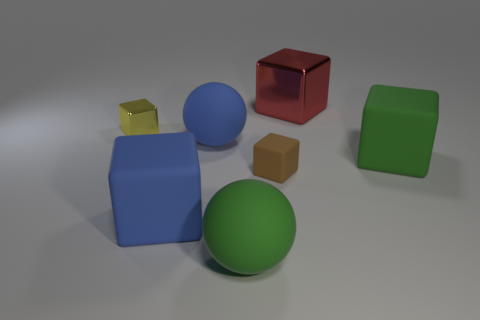Is the shape of the brown matte thing the same as the object that is on the left side of the big blue block?
Offer a very short reply. Yes. What material is the small cube in front of the shiny object on the left side of the small matte object?
Provide a succinct answer. Rubber. What color is the large metal block?
Provide a succinct answer. Red. Is the color of the big rubber object on the right side of the tiny matte cube the same as the ball that is in front of the brown block?
Provide a short and direct response. Yes. What is the size of the other metal object that is the same shape as the big red object?
Provide a succinct answer. Small. How many big matte blocks have the same color as the tiny matte block?
Make the answer very short. 0. How many things are either big rubber blocks to the right of the brown block or purple matte objects?
Provide a succinct answer. 1. The other large sphere that is the same material as the large blue sphere is what color?
Ensure brevity in your answer.  Green. Is there a brown thing of the same size as the blue block?
Make the answer very short. No. How many things are blue balls behind the brown cube or big objects that are to the right of the green rubber sphere?
Provide a succinct answer. 3. 